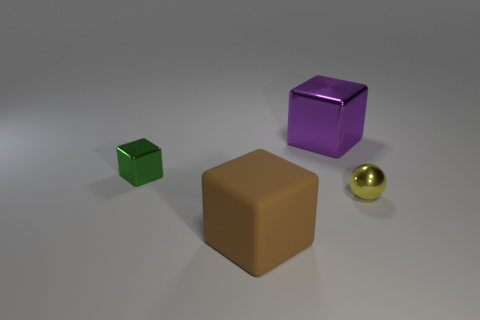Subtract 1 blocks. How many blocks are left? 2 Add 3 tiny blue objects. How many objects exist? 7 Subtract all cubes. How many objects are left? 1 Add 4 green metallic things. How many green metallic things exist? 5 Subtract 0 gray cylinders. How many objects are left? 4 Subtract all large matte blocks. Subtract all large rubber blocks. How many objects are left? 2 Add 2 small green things. How many small green things are left? 3 